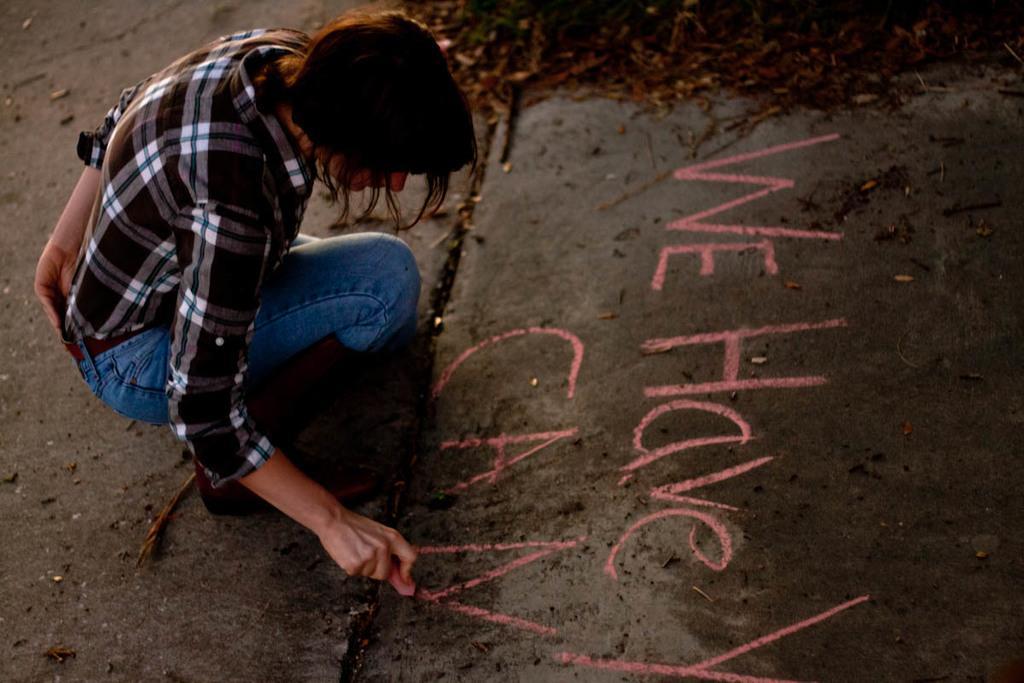In one or two sentences, can you explain what this image depicts? In this picture we can see a woman writing something on the ground with a pink chalk. In the background, we can see small sticks and leaves. 